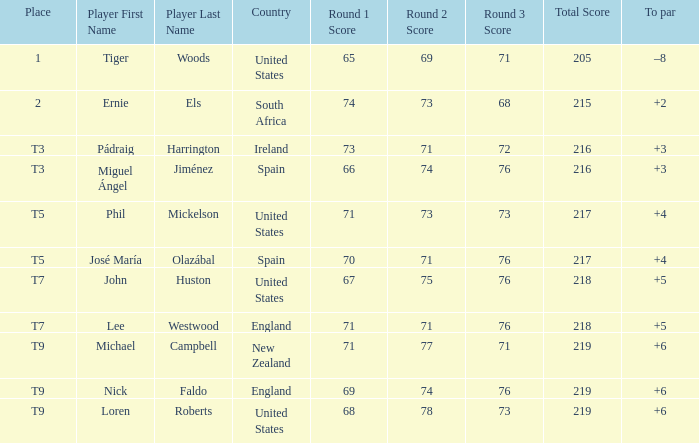What is To Par, when Place is "T5", and when Country is "United States"? 4.0. 